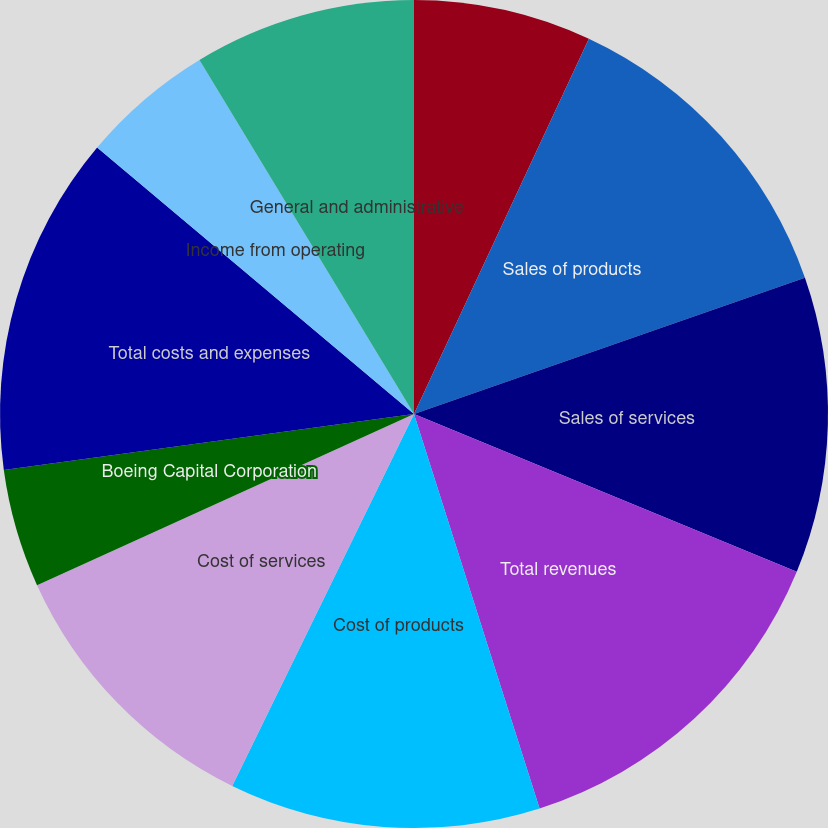Convert chart to OTSL. <chart><loc_0><loc_0><loc_500><loc_500><pie_chart><fcel>(Dollars in millions except<fcel>Sales of products<fcel>Sales of services<fcel>Total revenues<fcel>Cost of products<fcel>Cost of services<fcel>Boeing Capital Corporation<fcel>Total costs and expenses<fcel>Income from operating<fcel>General and administrative<nl><fcel>6.94%<fcel>12.72%<fcel>11.56%<fcel>13.87%<fcel>12.14%<fcel>10.98%<fcel>4.62%<fcel>13.29%<fcel>5.2%<fcel>8.67%<nl></chart> 